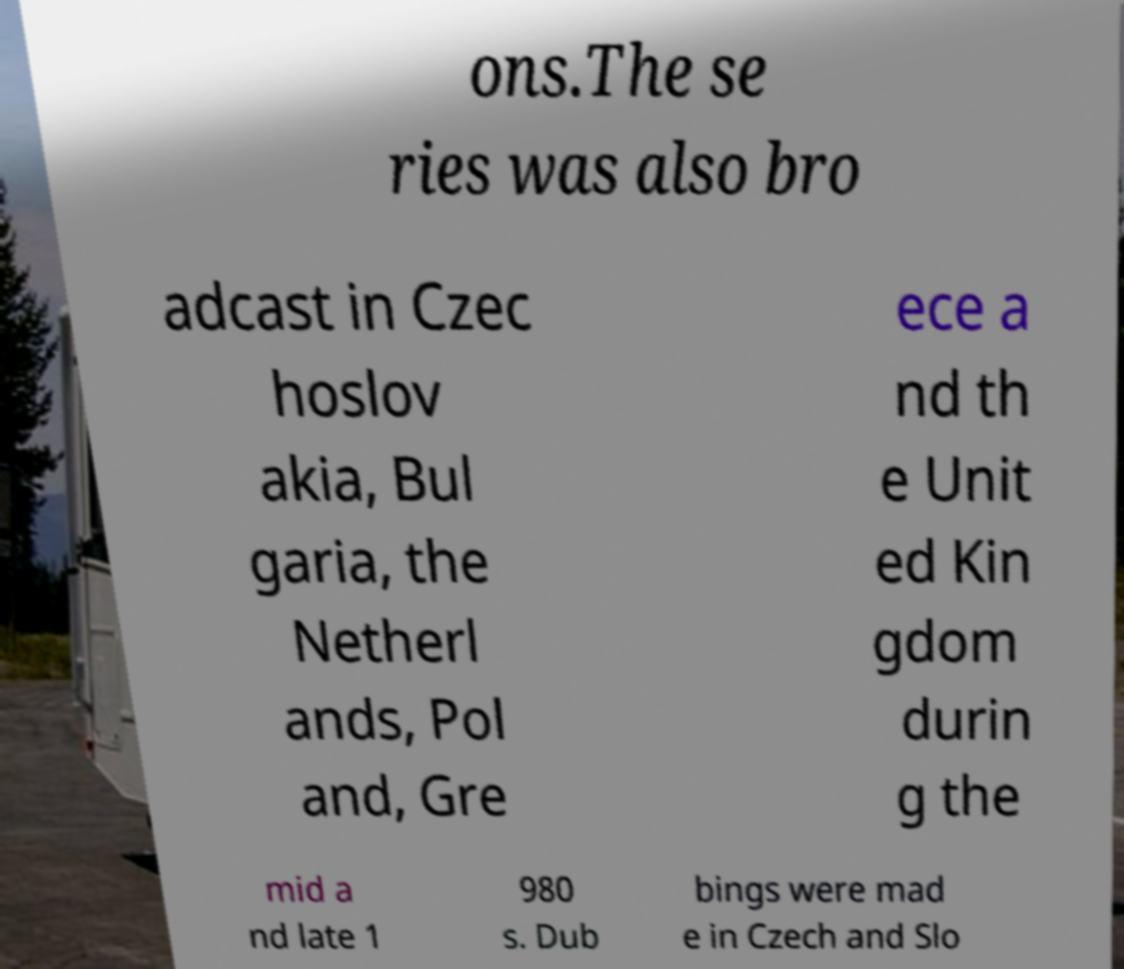For documentation purposes, I need the text within this image transcribed. Could you provide that? ons.The se ries was also bro adcast in Czec hoslov akia, Bul garia, the Netherl ands, Pol and, Gre ece a nd th e Unit ed Kin gdom durin g the mid a nd late 1 980 s. Dub bings were mad e in Czech and Slo 